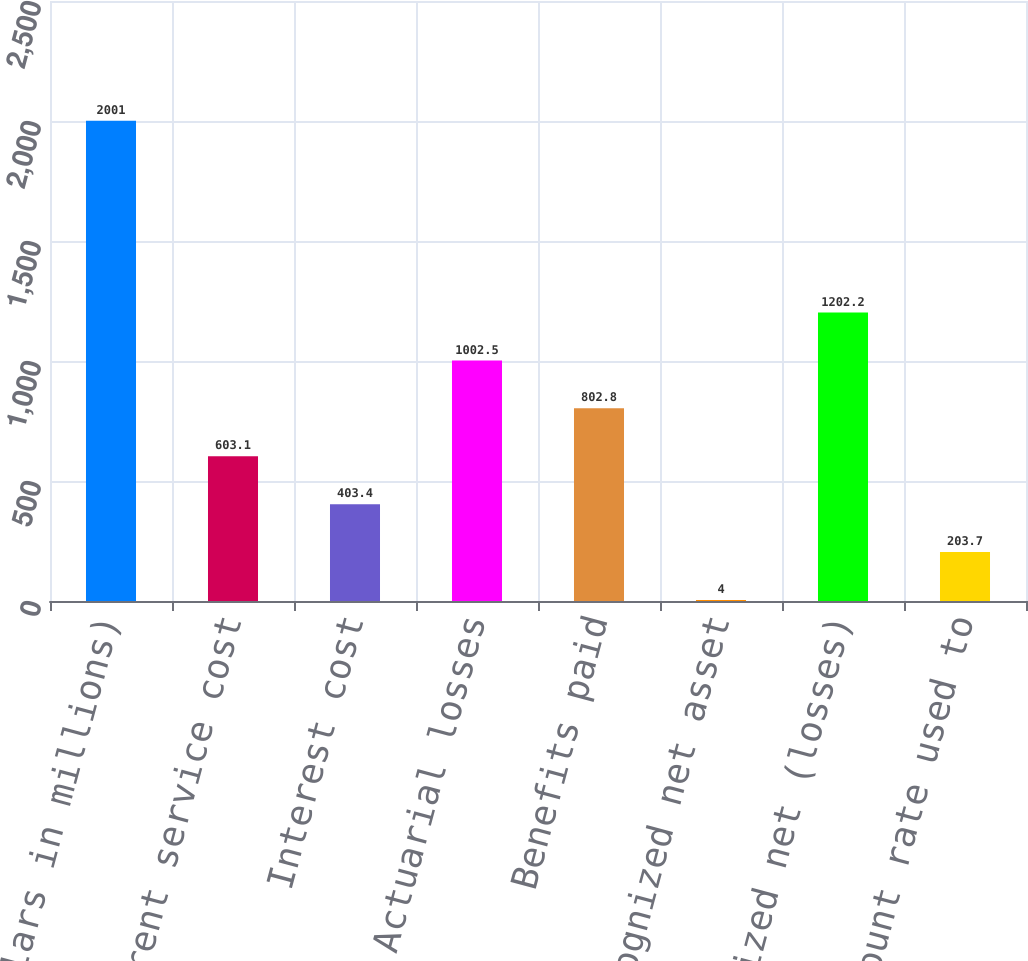Convert chart. <chart><loc_0><loc_0><loc_500><loc_500><bar_chart><fcel>(Dollars in millions)<fcel>Current service cost<fcel>Interest cost<fcel>Actuarial losses<fcel>Benefits paid<fcel>Unrecognized net asset<fcel>Unrecognized net (losses)<fcel>Discount rate used to<nl><fcel>2001<fcel>603.1<fcel>403.4<fcel>1002.5<fcel>802.8<fcel>4<fcel>1202.2<fcel>203.7<nl></chart> 